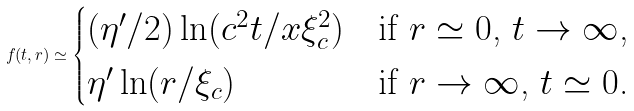<formula> <loc_0><loc_0><loc_500><loc_500>f ( t , r ) \simeq \begin{cases} ( \eta ^ { \prime } / 2 ) \ln ( c ^ { 2 } t / x \xi _ { c } ^ { 2 } ) & \text {if $r\simeq 0$, $t \to \infty$,} \\ \eta ^ { \prime } \ln ( r / \xi _ { c } ) & \text {if $r \to \infty$, $t \simeq 0$.} \end{cases}</formula> 